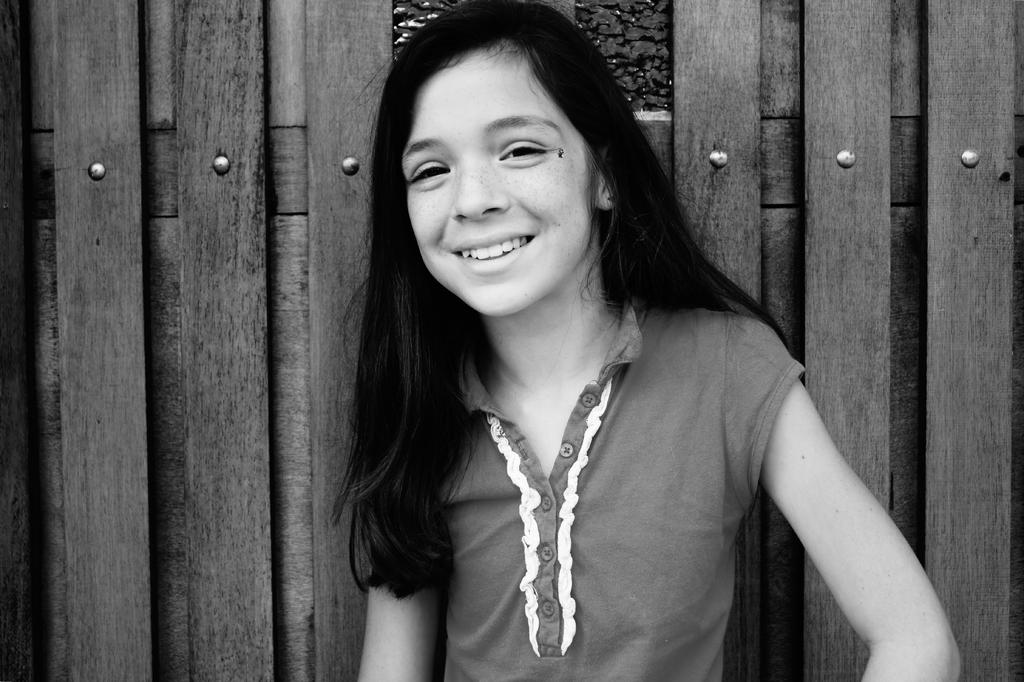Who is the main subject in the image? There is a girl in the image. What is the girl doing in the image? The girl is standing and smiling. What can be seen in the background of the image? There is a wooden wall in the background of the image. What verse is the girl reciting in the image? There is no indication in the image that the girl is reciting a verse, so it cannot be determined from the picture. 